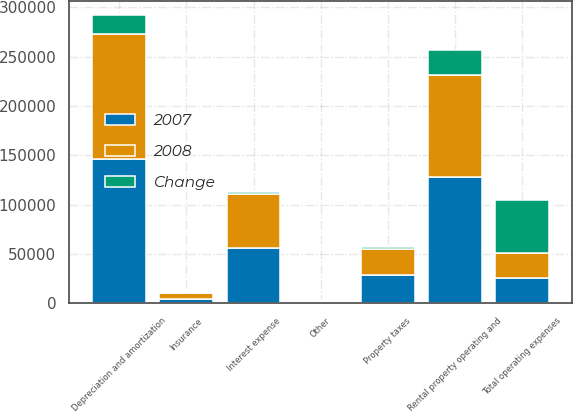<chart> <loc_0><loc_0><loc_500><loc_500><stacked_bar_chart><ecel><fcel>Rental property operating and<fcel>Property taxes<fcel>Insurance<fcel>Depreciation and amortization<fcel>Other<fcel>Total operating expenses<fcel>Interest expense<nl><fcel>2007<fcel>128202<fcel>28546<fcel>4683<fcel>146185<fcel>1547<fcel>25308<fcel>56492<nl><fcel>2008<fcel>102894<fcel>26408<fcel>5490<fcel>126557<fcel>902<fcel>25308<fcel>54118<nl><fcel>Change<fcel>25308<fcel>2138<fcel>807<fcel>19628<fcel>645<fcel>53901<fcel>2374<nl></chart> 